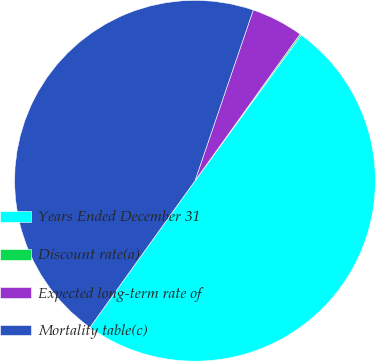Convert chart to OTSL. <chart><loc_0><loc_0><loc_500><loc_500><pie_chart><fcel>Years Ended December 31<fcel>Discount rate(a)<fcel>Expected long-term rate of<fcel>Mortality table(c)<nl><fcel>49.87%<fcel>0.13%<fcel>4.66%<fcel>45.34%<nl></chart> 